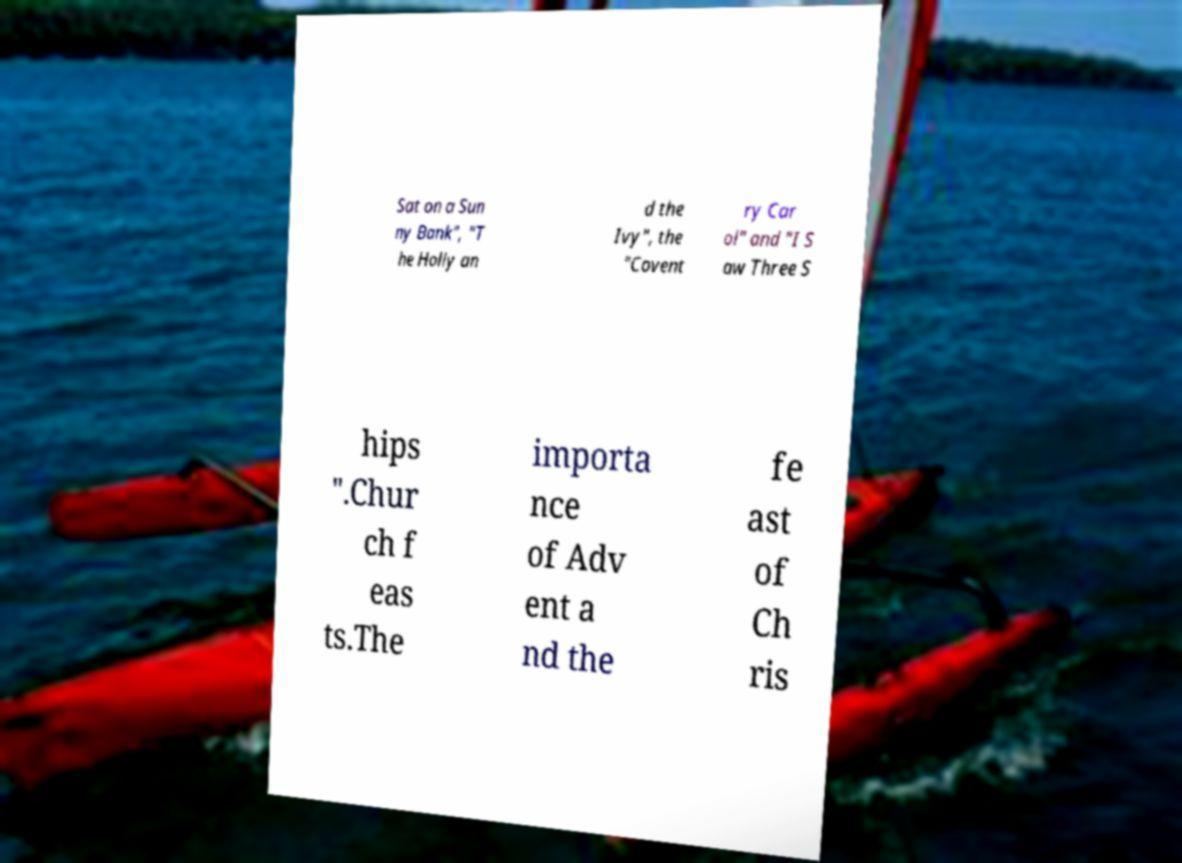There's text embedded in this image that I need extracted. Can you transcribe it verbatim? Sat on a Sun ny Bank", "T he Holly an d the Ivy", the "Covent ry Car ol" and "I S aw Three S hips ".Chur ch f eas ts.The importa nce of Adv ent a nd the fe ast of Ch ris 